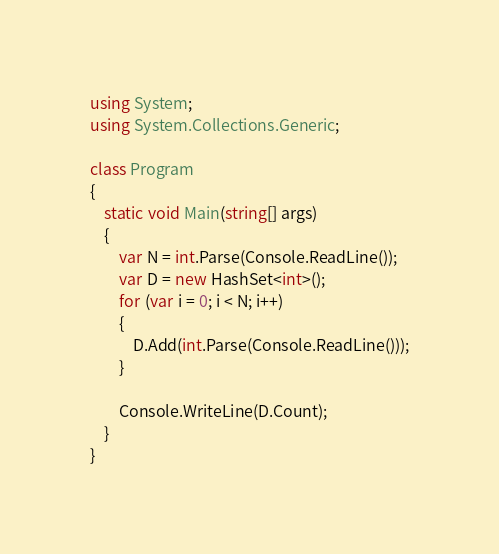<code> <loc_0><loc_0><loc_500><loc_500><_C#_>using System;
using System.Collections.Generic;

class Program
{
    static void Main(string[] args)
    {
        var N = int.Parse(Console.ReadLine());
        var D = new HashSet<int>();
        for (var i = 0; i < N; i++)
        {
            D.Add(int.Parse(Console.ReadLine()));
        }

        Console.WriteLine(D.Count);
    }
}</code> 